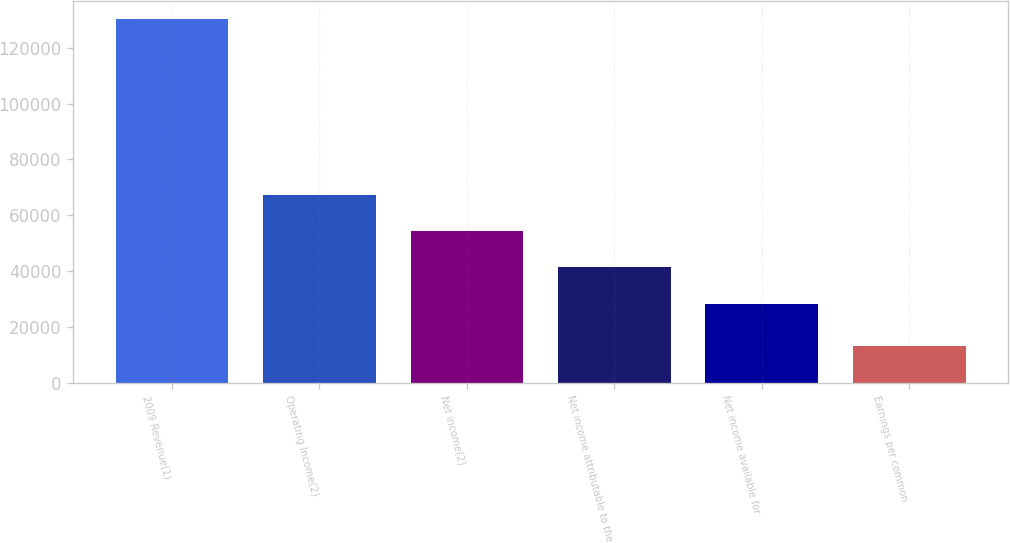Convert chart. <chart><loc_0><loc_0><loc_500><loc_500><bar_chart><fcel>2009 Revenue(1)<fcel>Operating Income(2)<fcel>Net income(2)<fcel>Net income attributable to the<fcel>Net income available for<fcel>Earnings per common<nl><fcel>130225<fcel>67349.4<fcel>54326.9<fcel>41304.4<fcel>28282<fcel>13022.9<nl></chart> 